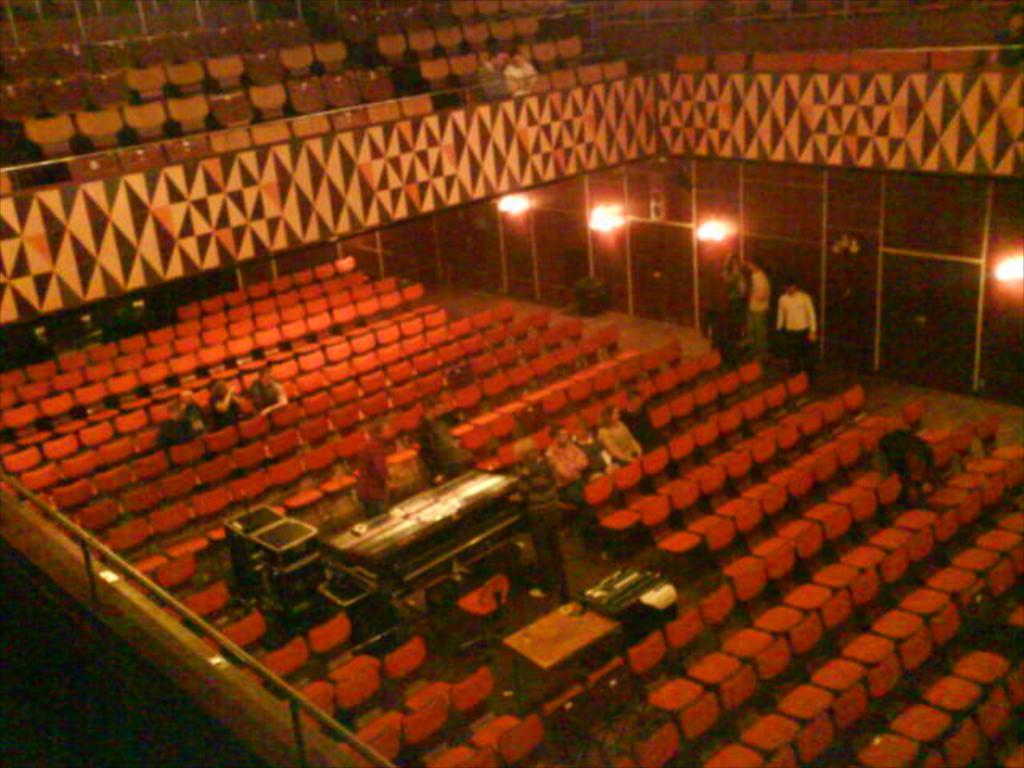What type of establishment is depicted in the image? The image appears to be a movie theater. What can be seen inside the movie theater? There are many chairs in the image, and people are sitting in them. Are there any visible light sources in the image? Yes, there are lights visible on the right side of the image. What type of pest can be seen crawling on the chairs in the image? There are no pests visible in the image; it only shows chairs and people sitting in them. What type of reading material is available for the audience in the image? The image does not show any reading material; it only depicts a movie theater with chairs and people sitting in them. 